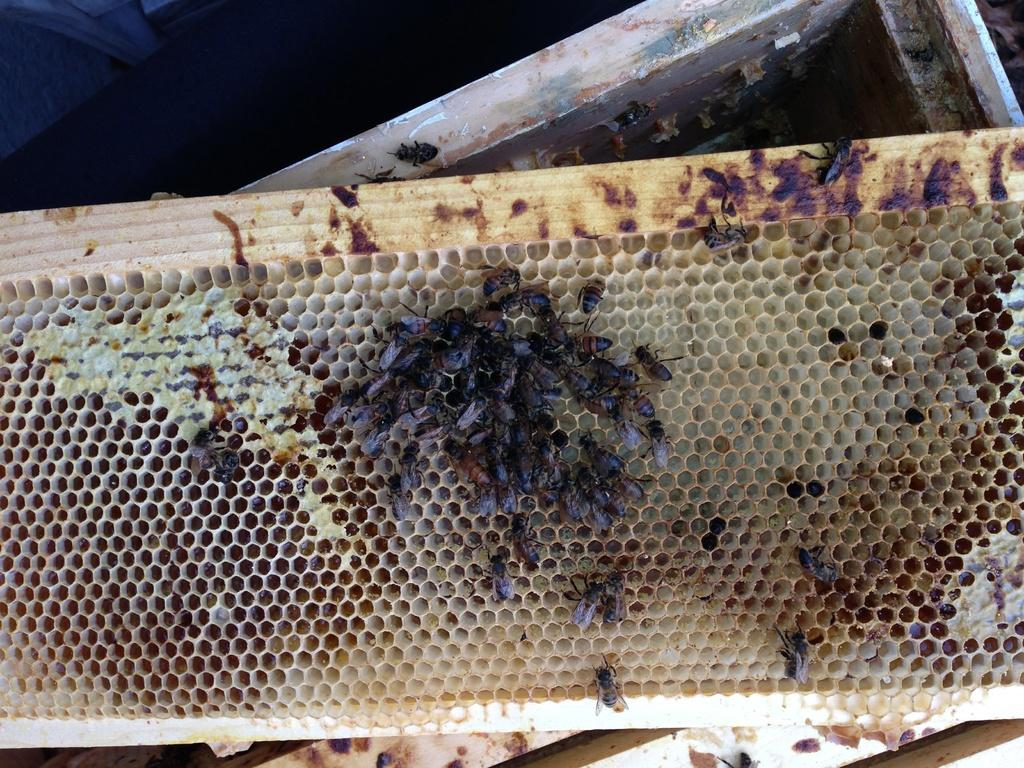What is the main subject of the image? The main subject of the image is a honeycomb. What can be seen on the honeycomb? There is a group of honey bees on the honeycomb. What decision did the honey bees make in the image? There is no indication in the image that the honey bees made a decision. --- Facts: 1. There is a group of people in the image. 2. The people are wearing hats. 3. The people are holding hands. 4. There is a large tree in the background. Absurd Topics: parrot, bicycle, ocean Conversation: How many people are in the image? There is a group of people in the image. What are the people wearing? The people are wearing hats. What are the people doing in the image? The people are holding hands. What can be seen in the background of the image? There is a large tree in the background. Reasoning: Let's think step by step in order to produce the conversation. We start by identifying the main subject of the image, which is the group of people. Then, we expand the conversation to include details about what the people are wearing and what they are doing. Finally, we describe the background of the image, which features a large tree. Each question is designed to elicit a specific detail about the image that is known from the provided facts. Absurd Question/Answer: What color is the parrot sitting on the bicycle in the image? There is no parrot or bicycle present in the image. --- Facts: 1. There is a car in the image. 2. The car is red. 3. The car has four wheels. 4. There is a road in the image. Absurd Topics: bird, mountain, river Conversation: What is the main subject of the image? The main subject of the image is a car. What color is the car? The car is red. How many wheels does the car have? The car has four wheels. What can be seen in the background of the image? There is a road in the image. Reasoning: Let's think step by step in order to produce the conversation. We start by identifying the main subject of the image, which is the car. Then, we expand the conversation to include details about the car's color and the number of wheels it has. Finally, we describe the background of the image, which features a road. Each question is designed to elicit a specific detail about the image that is known from the provided facts. Absurd Question/Answer: What type of bird can be seen flying over the mountain in the image? There is no bird or mountain present in the image. --- Facts: 1. There is a group of children playing in the image. 